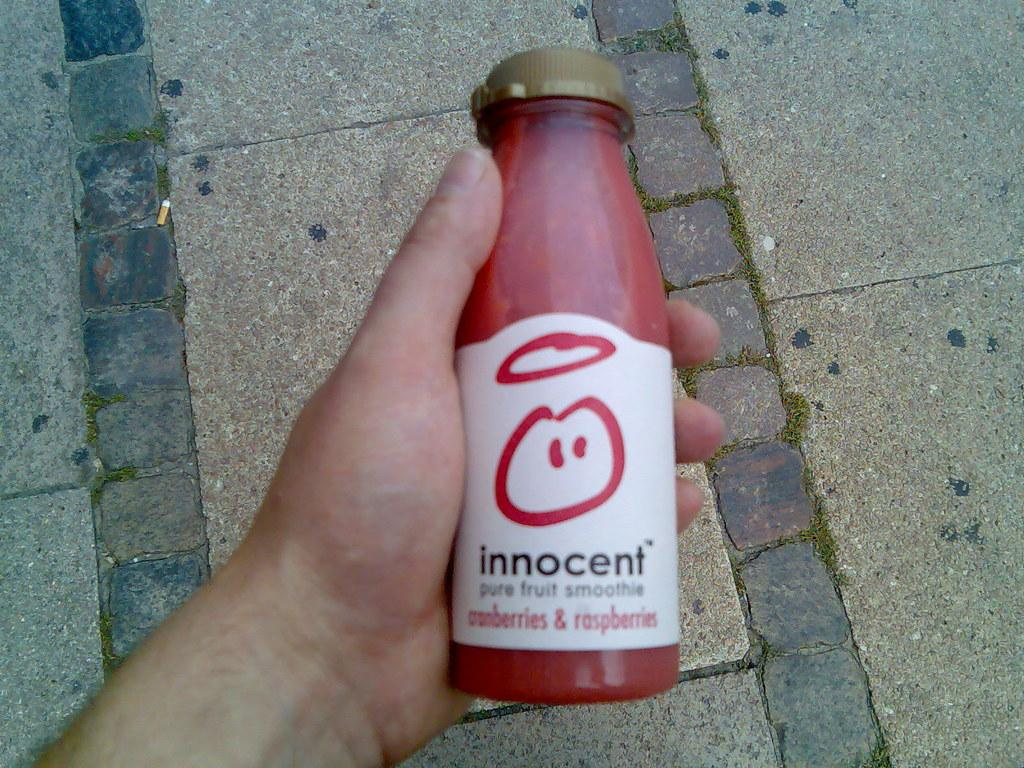What object is in the person's hand in the image? There is a bottle with a cap in the image, and a person is holding it. What feature of the bottle is mentioned in the image? The bottle has a cap. What can be seen beneath the person and the bottle in the image? The ground is visible in the image. How many stars can be seen on the person's lip in the image? There are no stars or reference to a person's lip in the image. 